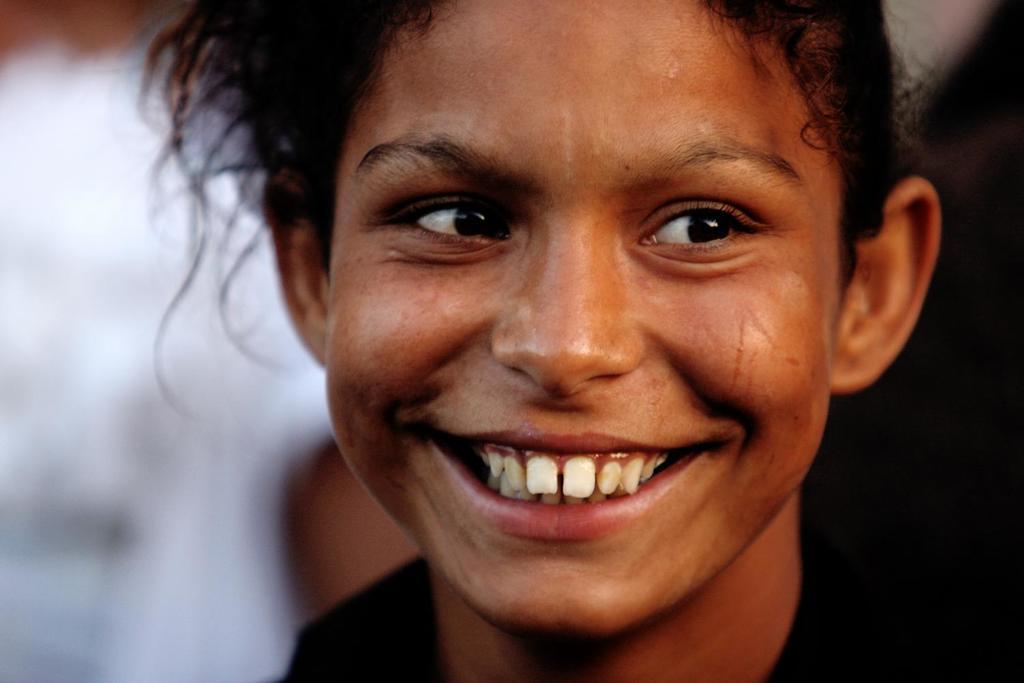How would you summarize this image in a sentence or two? In the foreground of this image, there is a girl having smile on her face and the background image is blurred. 